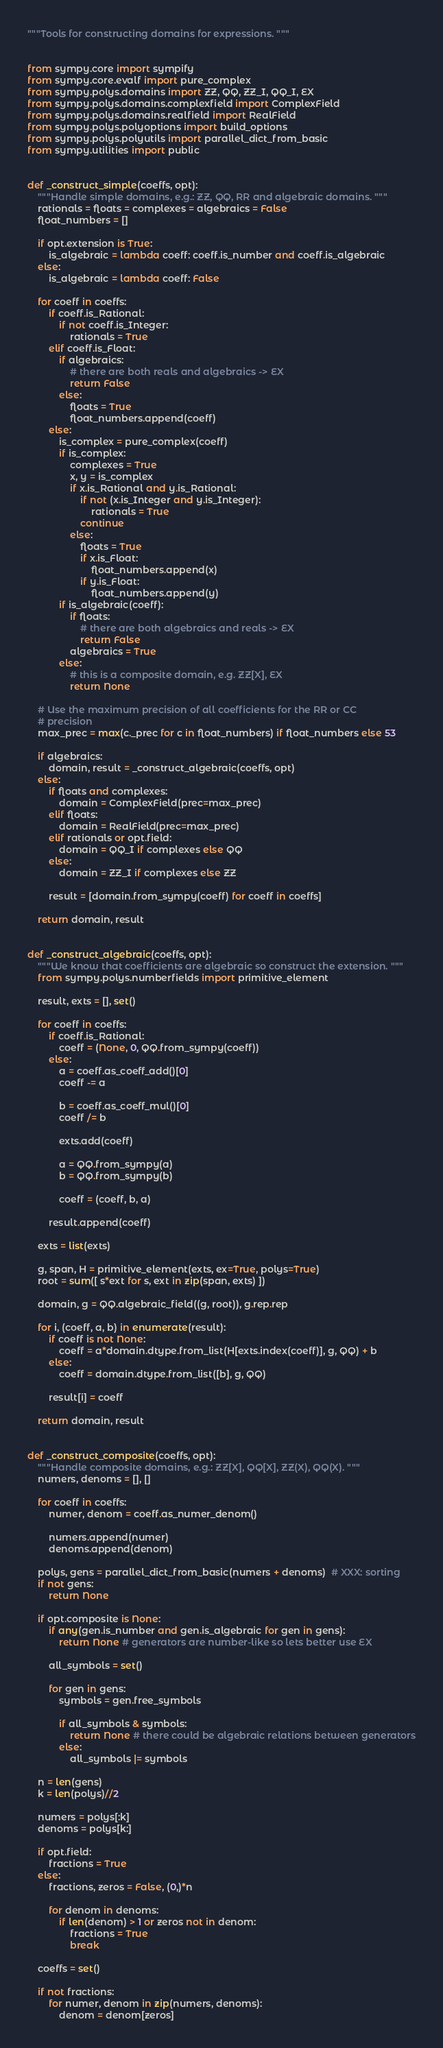Convert code to text. <code><loc_0><loc_0><loc_500><loc_500><_Python_>"""Tools for constructing domains for expressions. """


from sympy.core import sympify
from sympy.core.evalf import pure_complex
from sympy.polys.domains import ZZ, QQ, ZZ_I, QQ_I, EX
from sympy.polys.domains.complexfield import ComplexField
from sympy.polys.domains.realfield import RealField
from sympy.polys.polyoptions import build_options
from sympy.polys.polyutils import parallel_dict_from_basic
from sympy.utilities import public


def _construct_simple(coeffs, opt):
    """Handle simple domains, e.g.: ZZ, QQ, RR and algebraic domains. """
    rationals = floats = complexes = algebraics = False
    float_numbers = []

    if opt.extension is True:
        is_algebraic = lambda coeff: coeff.is_number and coeff.is_algebraic
    else:
        is_algebraic = lambda coeff: False

    for coeff in coeffs:
        if coeff.is_Rational:
            if not coeff.is_Integer:
                rationals = True
        elif coeff.is_Float:
            if algebraics:
                # there are both reals and algebraics -> EX
                return False
            else:
                floats = True
                float_numbers.append(coeff)
        else:
            is_complex = pure_complex(coeff)
            if is_complex:
                complexes = True
                x, y = is_complex
                if x.is_Rational and y.is_Rational:
                    if not (x.is_Integer and y.is_Integer):
                        rationals = True
                    continue
                else:
                    floats = True
                    if x.is_Float:
                        float_numbers.append(x)
                    if y.is_Float:
                        float_numbers.append(y)
            if is_algebraic(coeff):
                if floats:
                    # there are both algebraics and reals -> EX
                    return False
                algebraics = True
            else:
                # this is a composite domain, e.g. ZZ[X], EX
                return None

    # Use the maximum precision of all coefficients for the RR or CC
    # precision
    max_prec = max(c._prec for c in float_numbers) if float_numbers else 53

    if algebraics:
        domain, result = _construct_algebraic(coeffs, opt)
    else:
        if floats and complexes:
            domain = ComplexField(prec=max_prec)
        elif floats:
            domain = RealField(prec=max_prec)
        elif rationals or opt.field:
            domain = QQ_I if complexes else QQ
        else:
            domain = ZZ_I if complexes else ZZ

        result = [domain.from_sympy(coeff) for coeff in coeffs]

    return domain, result


def _construct_algebraic(coeffs, opt):
    """We know that coefficients are algebraic so construct the extension. """
    from sympy.polys.numberfields import primitive_element

    result, exts = [], set()

    for coeff in coeffs:
        if coeff.is_Rational:
            coeff = (None, 0, QQ.from_sympy(coeff))
        else:
            a = coeff.as_coeff_add()[0]
            coeff -= a

            b = coeff.as_coeff_mul()[0]
            coeff /= b

            exts.add(coeff)

            a = QQ.from_sympy(a)
            b = QQ.from_sympy(b)

            coeff = (coeff, b, a)

        result.append(coeff)

    exts = list(exts)

    g, span, H = primitive_element(exts, ex=True, polys=True)
    root = sum([ s*ext for s, ext in zip(span, exts) ])

    domain, g = QQ.algebraic_field((g, root)), g.rep.rep

    for i, (coeff, a, b) in enumerate(result):
        if coeff is not None:
            coeff = a*domain.dtype.from_list(H[exts.index(coeff)], g, QQ) + b
        else:
            coeff = domain.dtype.from_list([b], g, QQ)

        result[i] = coeff

    return domain, result


def _construct_composite(coeffs, opt):
    """Handle composite domains, e.g.: ZZ[X], QQ[X], ZZ(X), QQ(X). """
    numers, denoms = [], []

    for coeff in coeffs:
        numer, denom = coeff.as_numer_denom()

        numers.append(numer)
        denoms.append(denom)

    polys, gens = parallel_dict_from_basic(numers + denoms)  # XXX: sorting
    if not gens:
        return None

    if opt.composite is None:
        if any(gen.is_number and gen.is_algebraic for gen in gens):
            return None # generators are number-like so lets better use EX

        all_symbols = set()

        for gen in gens:
            symbols = gen.free_symbols

            if all_symbols & symbols:
                return None # there could be algebraic relations between generators
            else:
                all_symbols |= symbols

    n = len(gens)
    k = len(polys)//2

    numers = polys[:k]
    denoms = polys[k:]

    if opt.field:
        fractions = True
    else:
        fractions, zeros = False, (0,)*n

        for denom in denoms:
            if len(denom) > 1 or zeros not in denom:
                fractions = True
                break

    coeffs = set()

    if not fractions:
        for numer, denom in zip(numers, denoms):
            denom = denom[zeros]
</code> 